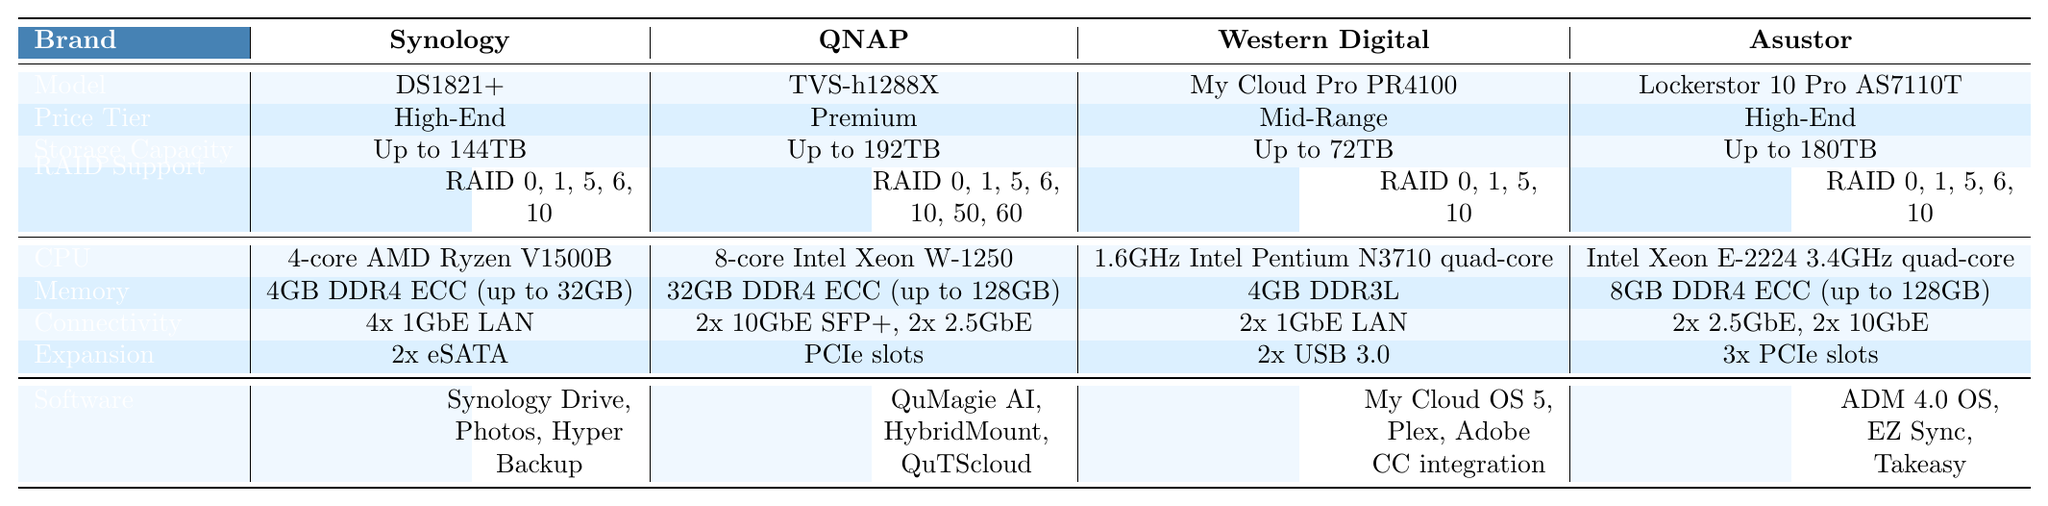What is the storage capacity of the QNAP TVS-h1288X? The table lists the storage capacity of each NAS system. For QNAP TVS-h1288X, it states "Up to 192TB."
Answer: Up to 192TB Which NAS systems support RAID 50 and RAID 60? The only NAS system that supports RAID 50 and RAID 60 is the QNAP TVS-h1288X, as shown in the RAID Support section of the table.
Answer: QNAP TVS-h1288X What is the difference in maximum storage capacity between the Synology DS1821+ and the Western Digital My Cloud Pro PR4100? The maximum storage capacity for Synology DS1821+ is 144TB, while for Western Digital My Cloud Pro PR4100 it is 72TB. The difference is calculated as 144TB - 72TB = 72TB.
Answer: 72TB Does the Asustor Lockerstor 10 Pro AS7110T support RAID 5? Looking at the RAID Support for Asustor Lockerstor 10 Pro AS7110T, it lists RAID 0, 1, 5, 6, and 10. Since RAID 5 is included, the answer is yes.
Answer: Yes Which NAS has the highest memory capacity and what is it? By inspecting the Memory entries for each NAS system, the QNAP TVS-h1288X shows 32GB (expandable to 128GB), which is the highest.
Answer: 32GB (expandable to 128GB) How many NAS systems have expandable RAM? Checking the Memory specifications, the Synology DS1821+ (expandable to 32GB), QNAP TVS-h1288X (expandable to 128GB), and Asustor Lockerstor 10 Pro AS7110T (expandable to 128GB) all feature expandable RAM. Therefore, there are three NAS systems with this feature.
Answer: 3 Which brand offers the most USB ports for expansion? The table shows that Western Digital My Cloud Pro PR4100 has 2 USB 3.0 ports, while QNAP TVS-h1288X has PCIe slots but does not specify USB ports. The Asustor Lockerstor 10 Pro AS7110T has 3 PCIe slots. Since Synology DS1821+ has 2 eSATA ports, there are no USB ports exceeding 2.
Answer: Western Digital Which models offer advanced connectivity options such as 10GbE ports? The QNAP TVS-h1288X has 2x 10GbE SFP+ and 2x 2.5GbE ports, and the Asustor Lockerstor 10 Pro AS7110T includes 2x 2.5GbE and 2x 10GbE ports. Therefore, two models offer advanced connectivity options.
Answer: 2 models If someone prefers a high-end system, which options do they have? The high-end options listed in the table are Synology DS1821+ and Asustor Lockerstor 10 Pro AS7110T.
Answer: 2 options What can you conclude about the CPU performance of NAS systems in the high-end and premium tiers? High-end (Synology and Asustor) have powerful CPUs (AMD Ryzen and Intel Xeon), while the premium (QNAP) system also has a strong CPU (Intel Xeon) but not as high as the Asustor’s. The performance generally indicates that these systems are designed for demanding tasks, suggesting that users can expect better performance in high-end models compared to mid-range models like Western Digital.
Answer: High-end and premium NAS systems have superior CPUs 